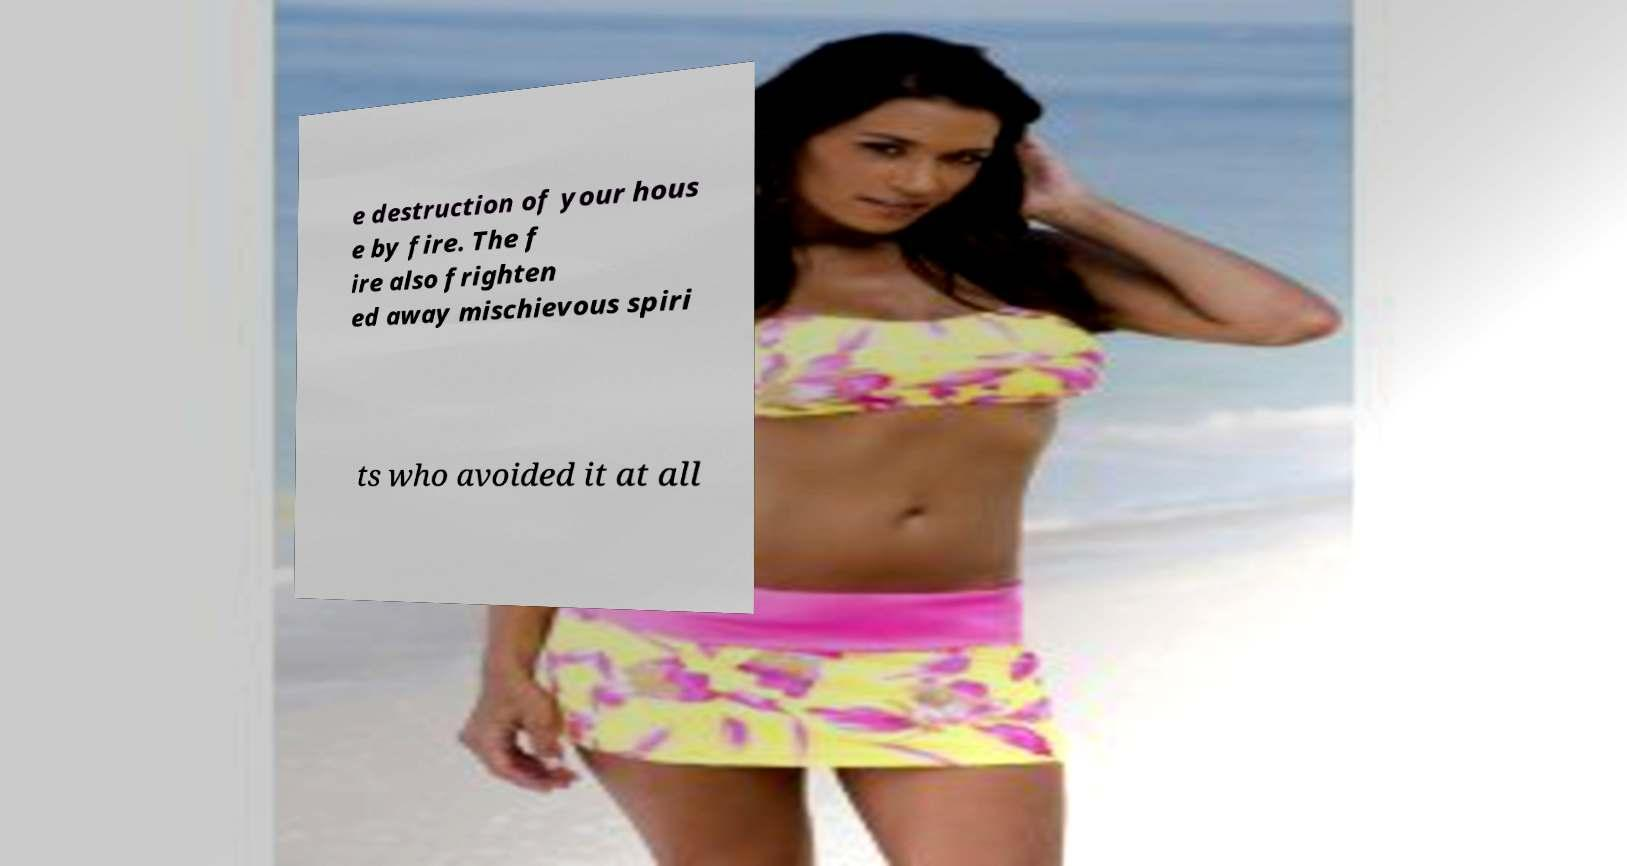Can you accurately transcribe the text from the provided image for me? e destruction of your hous e by fire. The f ire also frighten ed away mischievous spiri ts who avoided it at all 